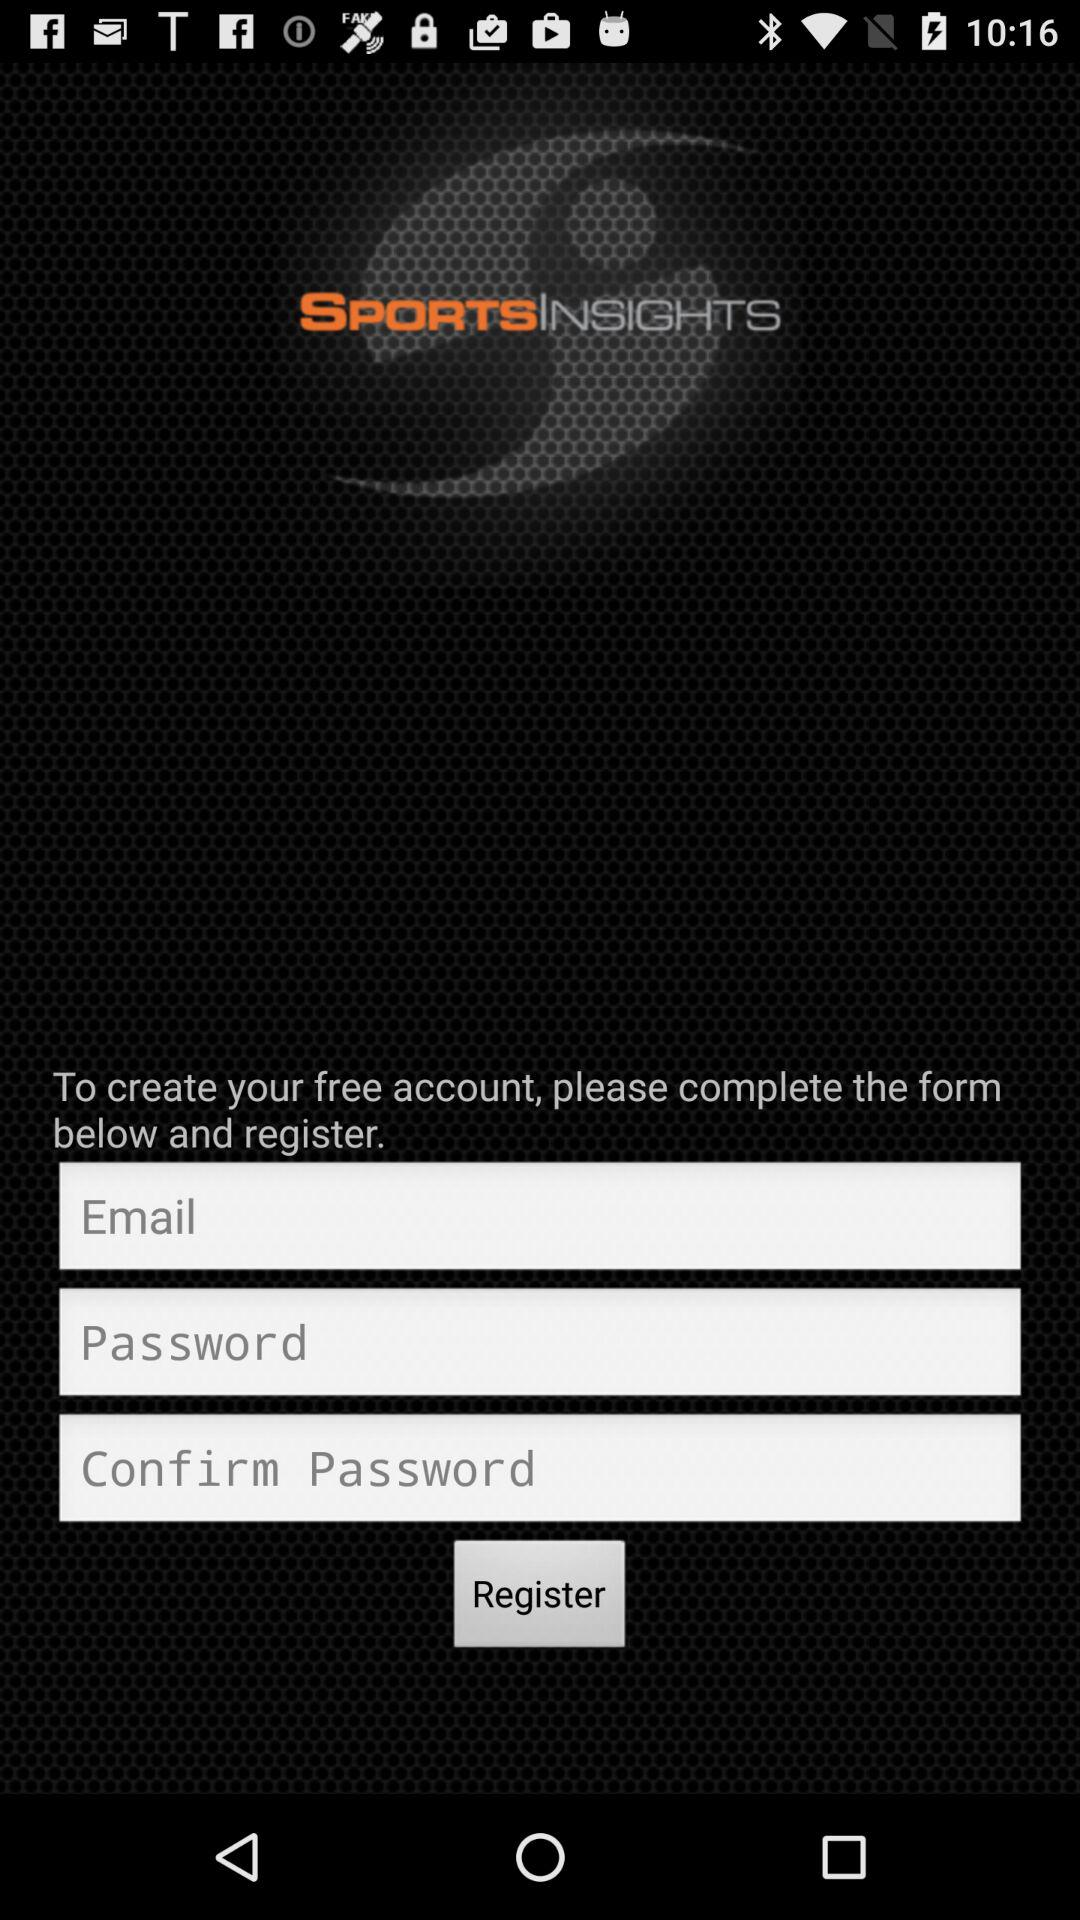How many characters are required for the password?
When the provided information is insufficient, respond with <no answer>. <no answer> 